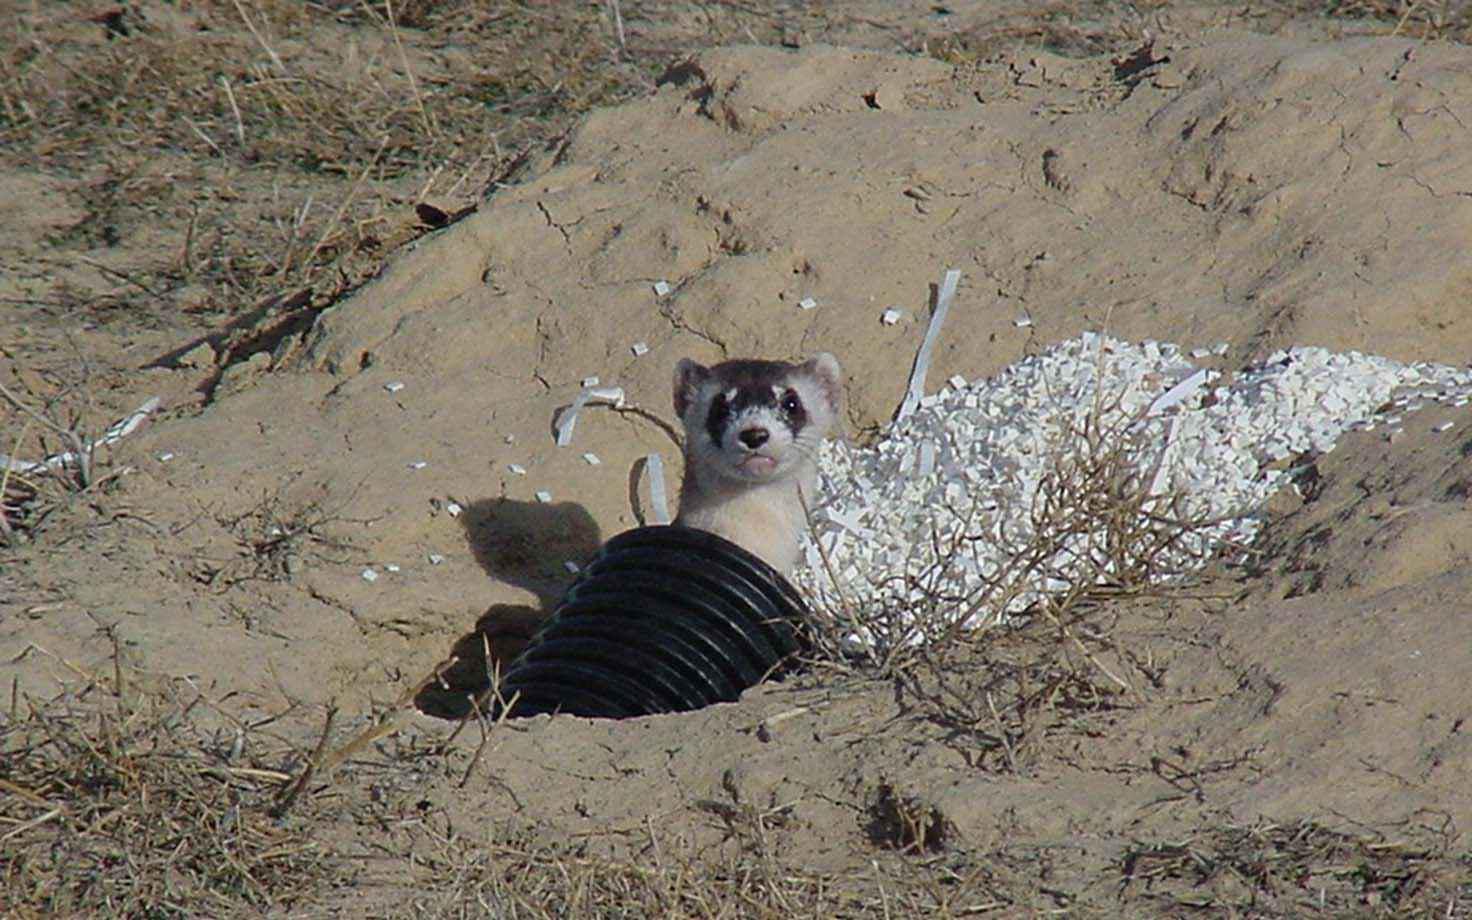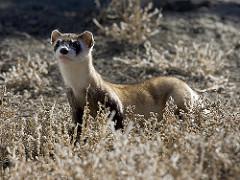The first image is the image on the left, the second image is the image on the right. Given the left and right images, does the statement "There are two animals in total." hold true? Answer yes or no. Yes. The first image is the image on the left, the second image is the image on the right. Considering the images on both sides, is "An image shows exactly one ferret partly emerged from a hole in the ground, with no manmade material visible." valid? Answer yes or no. No. 